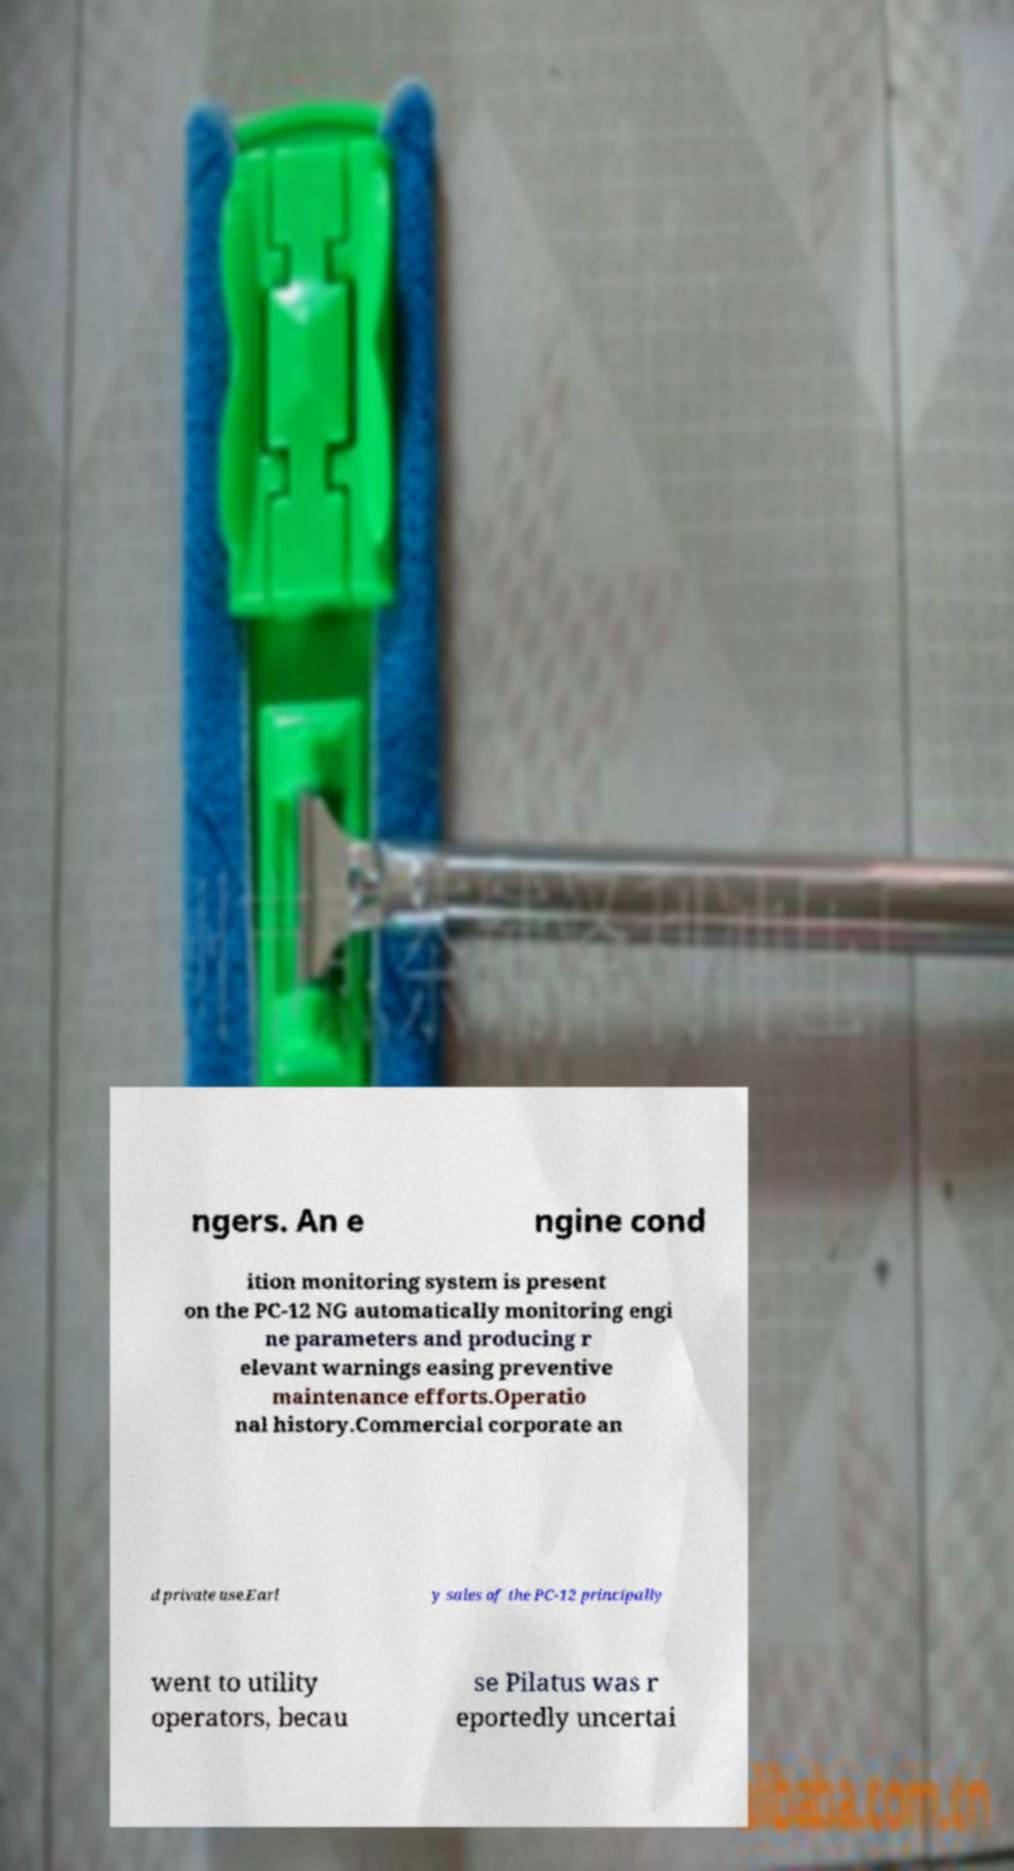I need the written content from this picture converted into text. Can you do that? ngers. An e ngine cond ition monitoring system is present on the PC-12 NG automatically monitoring engi ne parameters and producing r elevant warnings easing preventive maintenance efforts.Operatio nal history.Commercial corporate an d private use.Earl y sales of the PC-12 principally went to utility operators, becau se Pilatus was r eportedly uncertai 